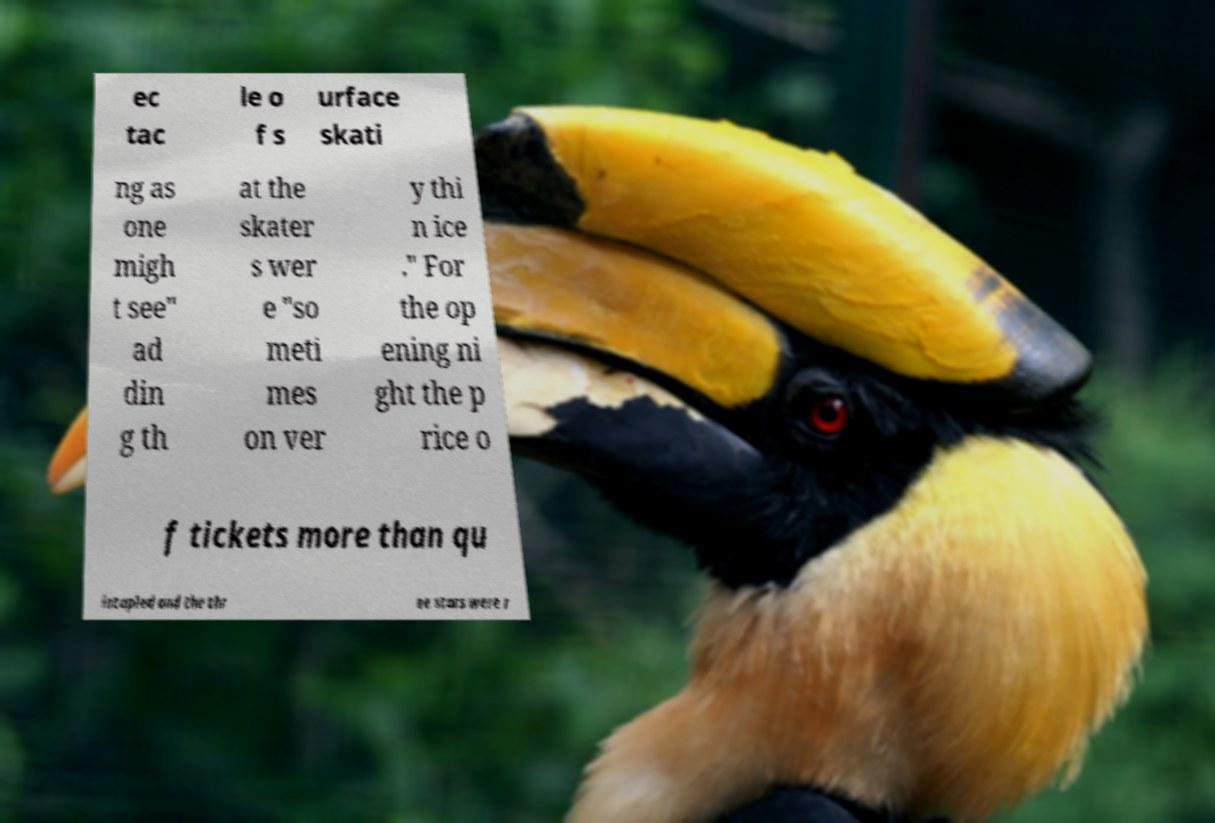Could you assist in decoding the text presented in this image and type it out clearly? ec tac le o f s urface skati ng as one migh t see" ad din g th at the skater s wer e "so meti mes on ver y thi n ice ." For the op ening ni ght the p rice o f tickets more than qu intupled and the thr ee stars were r 